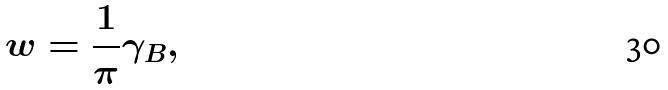<formula> <loc_0><loc_0><loc_500><loc_500>w = \frac { 1 } { \pi } \gamma _ { B } ,</formula> 